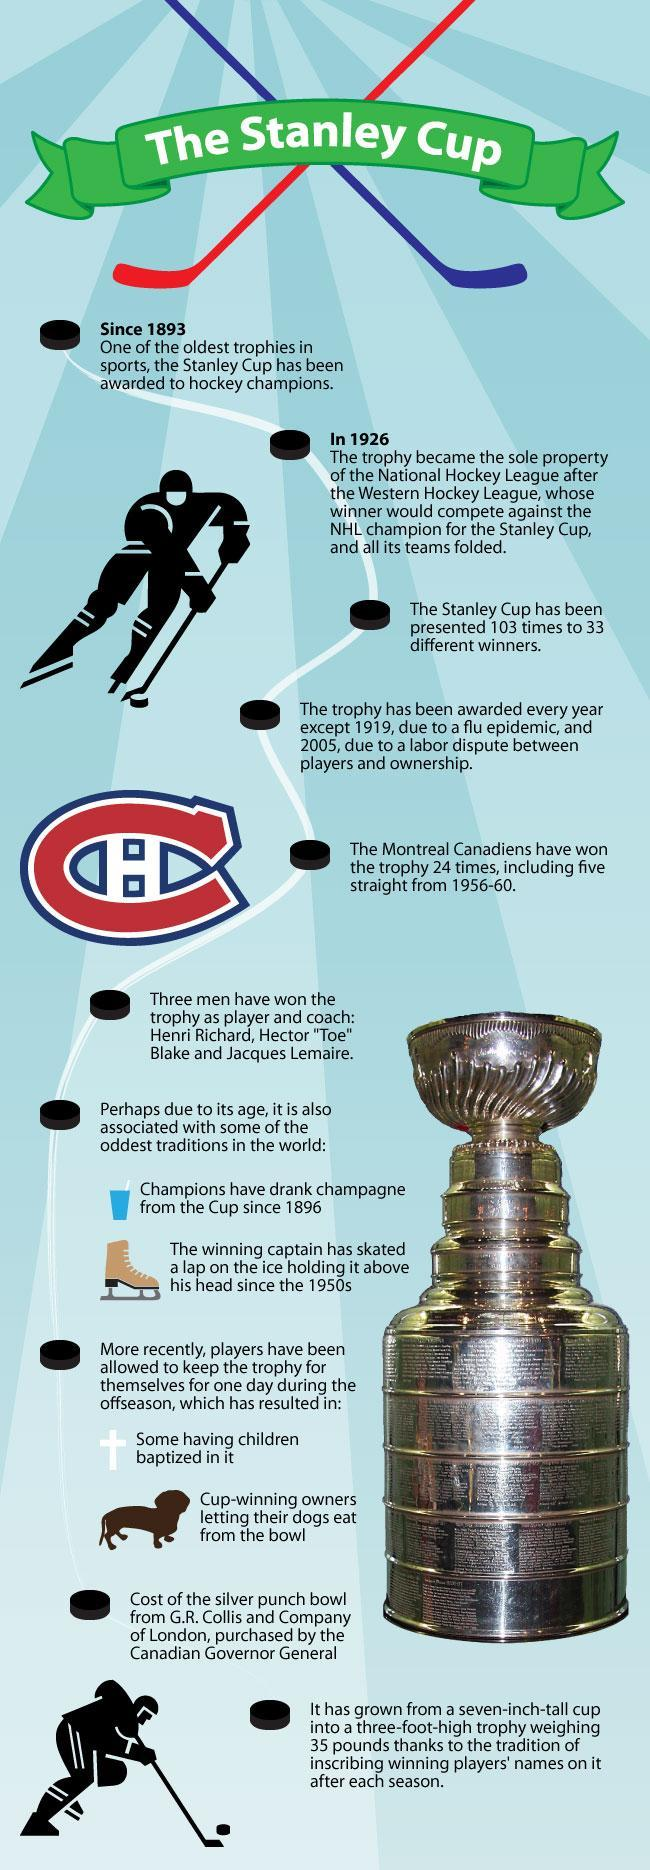How many persons images are in this infographic?
Answer the question with a short phrase. 2 